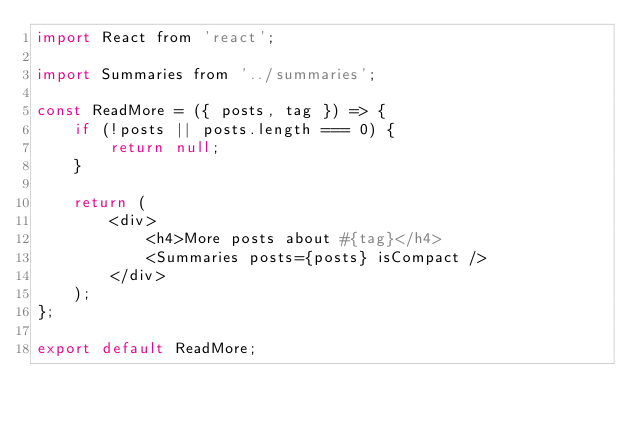<code> <loc_0><loc_0><loc_500><loc_500><_JavaScript_>import React from 'react';

import Summaries from '../summaries';

const ReadMore = ({ posts, tag }) => {
    if (!posts || posts.length === 0) {
        return null;
    }

    return (
        <div>
            <h4>More posts about #{tag}</h4>
            <Summaries posts={posts} isCompact />
        </div>
    );
};

export default ReadMore;
</code> 